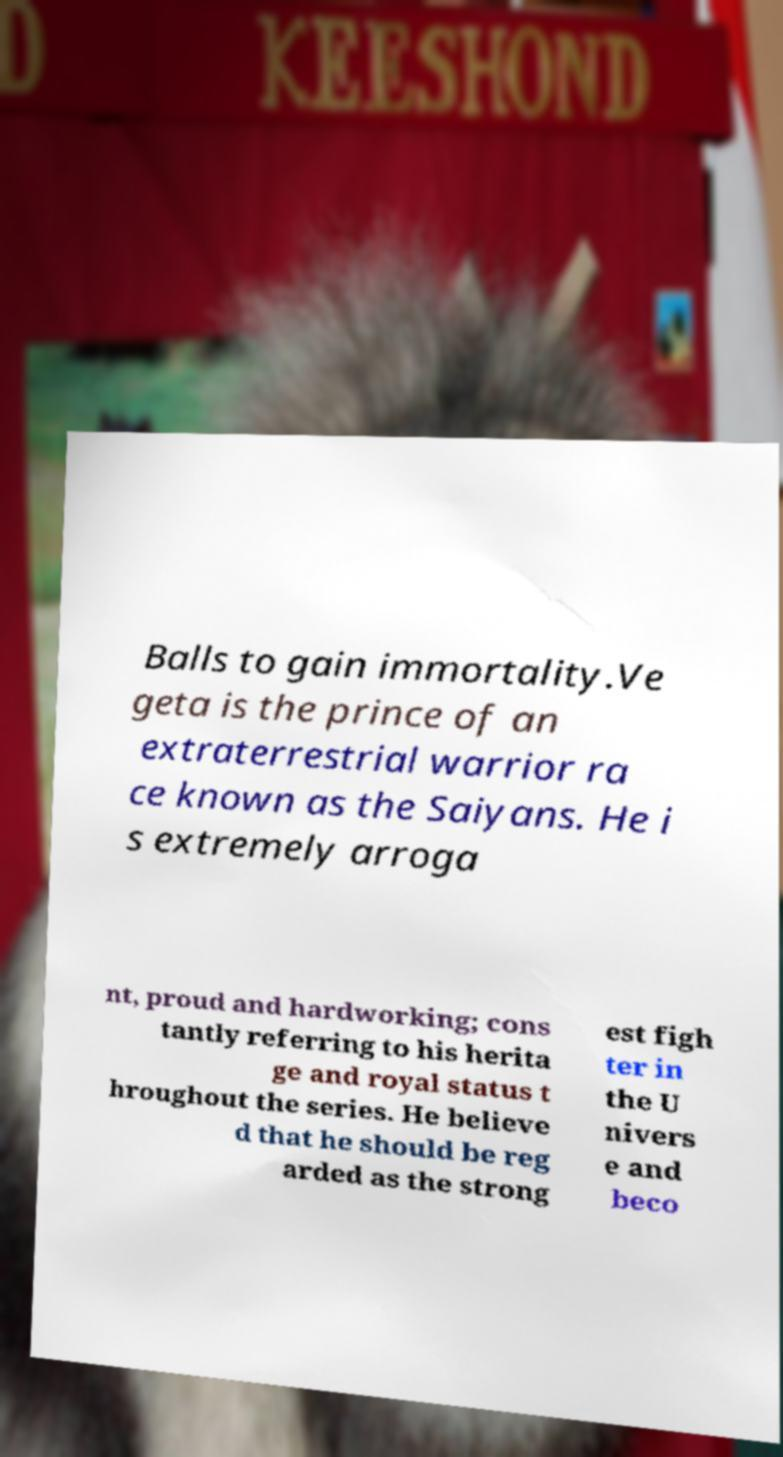Please identify and transcribe the text found in this image. Balls to gain immortality.Ve geta is the prince of an extraterrestrial warrior ra ce known as the Saiyans. He i s extremely arroga nt, proud and hardworking; cons tantly referring to his herita ge and royal status t hroughout the series. He believe d that he should be reg arded as the strong est figh ter in the U nivers e and beco 